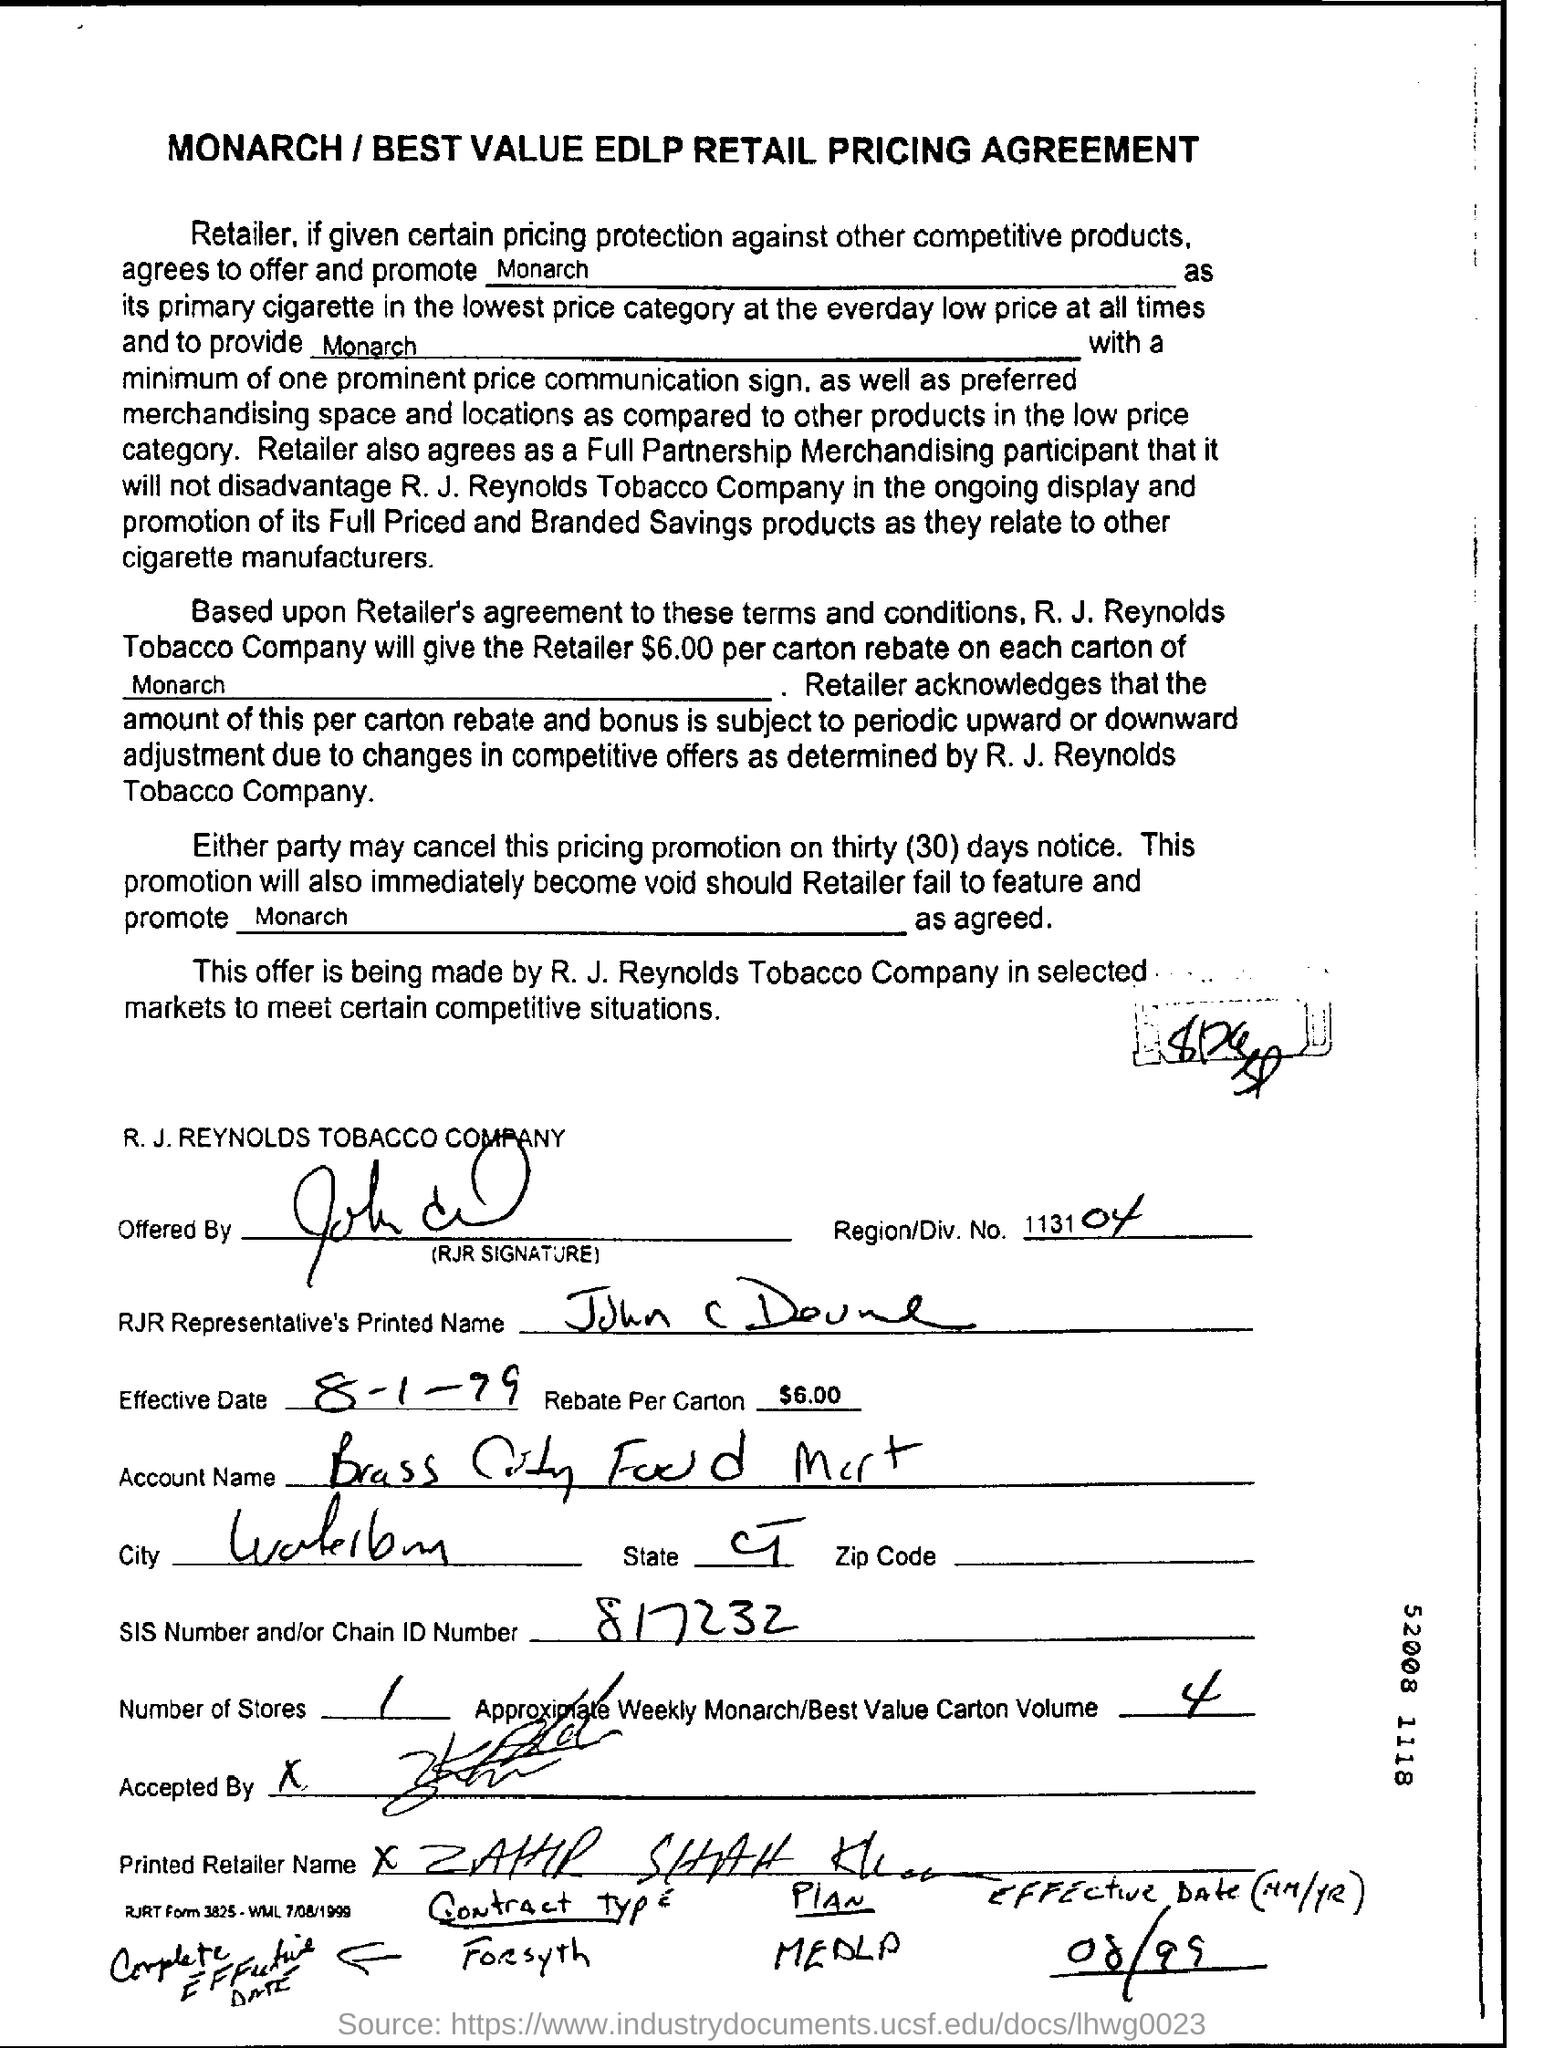Draw attention to some important aspects in this diagram. The heading of this document is "MONARCH / BEST VALUE EDLP RETAIL PRICING AGREEMENT. The chain ID number is 817232... The R. J. Reynolds Tobacco Company is a company. The region number is 113104. The Rebate Per Carton Field contains the amount of $6.00. 